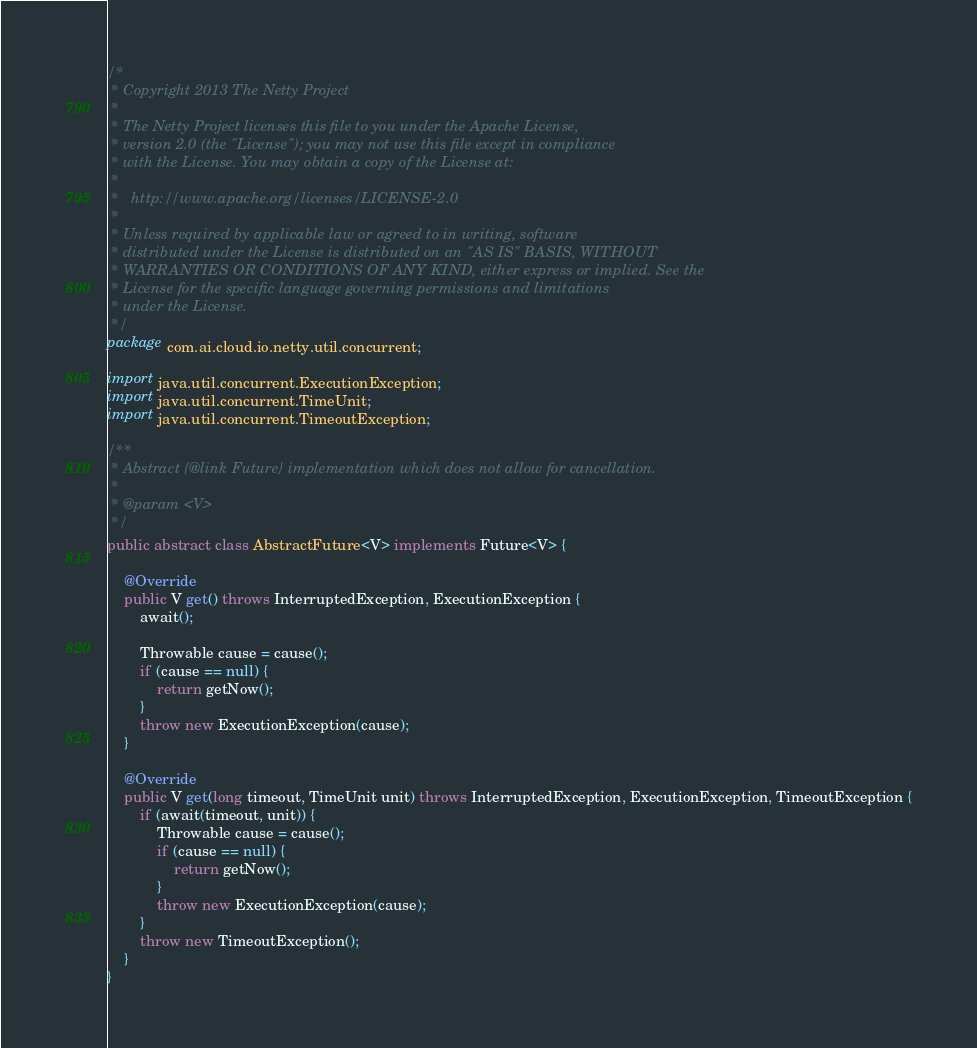Convert code to text. <code><loc_0><loc_0><loc_500><loc_500><_Java_>/*
 * Copyright 2013 The Netty Project
 *
 * The Netty Project licenses this file to you under the Apache License,
 * version 2.0 (the "License"); you may not use this file except in compliance
 * with the License. You may obtain a copy of the License at:
 *
 *   http://www.apache.org/licenses/LICENSE-2.0
 *
 * Unless required by applicable law or agreed to in writing, software
 * distributed under the License is distributed on an "AS IS" BASIS, WITHOUT
 * WARRANTIES OR CONDITIONS OF ANY KIND, either express or implied. See the
 * License for the specific language governing permissions and limitations
 * under the License.
 */
package com.ai.cloud.io.netty.util.concurrent;

import java.util.concurrent.ExecutionException;
import java.util.concurrent.TimeUnit;
import java.util.concurrent.TimeoutException;

/**
 * Abstract {@link Future} implementation which does not allow for cancellation.
 *
 * @param <V>
 */
public abstract class AbstractFuture<V> implements Future<V> {

    @Override
    public V get() throws InterruptedException, ExecutionException {
        await();

        Throwable cause = cause();
        if (cause == null) {
            return getNow();
        }
        throw new ExecutionException(cause);
    }

    @Override
    public V get(long timeout, TimeUnit unit) throws InterruptedException, ExecutionException, TimeoutException {
        if (await(timeout, unit)) {
            Throwable cause = cause();
            if (cause == null) {
                return getNow();
            }
            throw new ExecutionException(cause);
        }
        throw new TimeoutException();
    }
}
</code> 